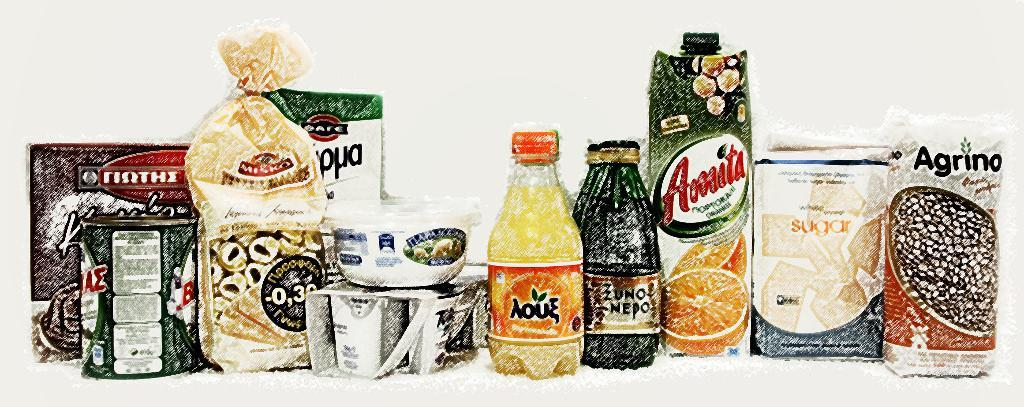What types of containers are visible in the image? There are bottles, a bowl, and boxes in the image. What is the color of the background in the image? The background of the image is white. Can you tell me how many friends are depicted in the image? There are no people or friends present in the image; it only features containers and a white background. Is there any fiction being read or written in the image? There is no reference to any reading or writing material in the image, so it cannot be determined if there is any fiction present. 